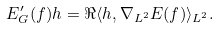<formula> <loc_0><loc_0><loc_500><loc_500>E _ { G } ^ { \prime } ( f ) h = \Re \langle h , \nabla _ { L ^ { 2 } } E ( f ) \rangle _ { L ^ { 2 } } .</formula> 